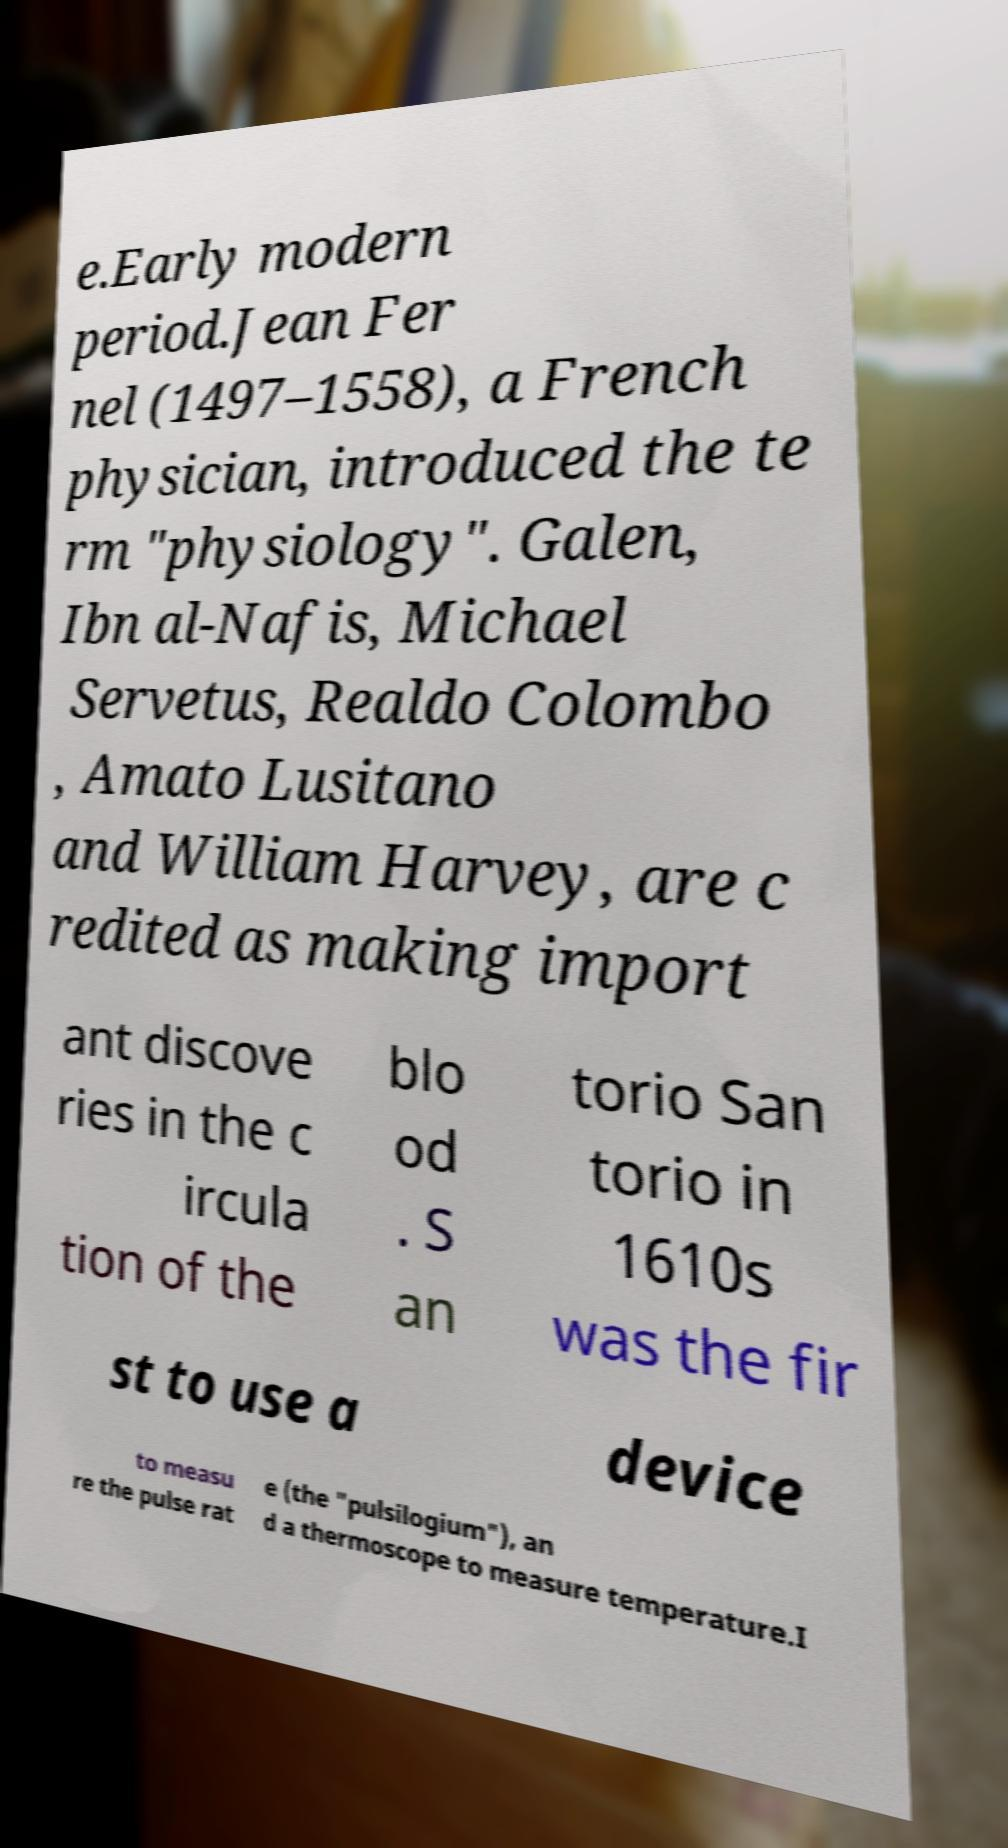I need the written content from this picture converted into text. Can you do that? e.Early modern period.Jean Fer nel (1497–1558), a French physician, introduced the te rm "physiology". Galen, Ibn al-Nafis, Michael Servetus, Realdo Colombo , Amato Lusitano and William Harvey, are c redited as making import ant discove ries in the c ircula tion of the blo od . S an torio San torio in 1610s was the fir st to use a device to measu re the pulse rat e (the "pulsilogium"), an d a thermoscope to measure temperature.I 